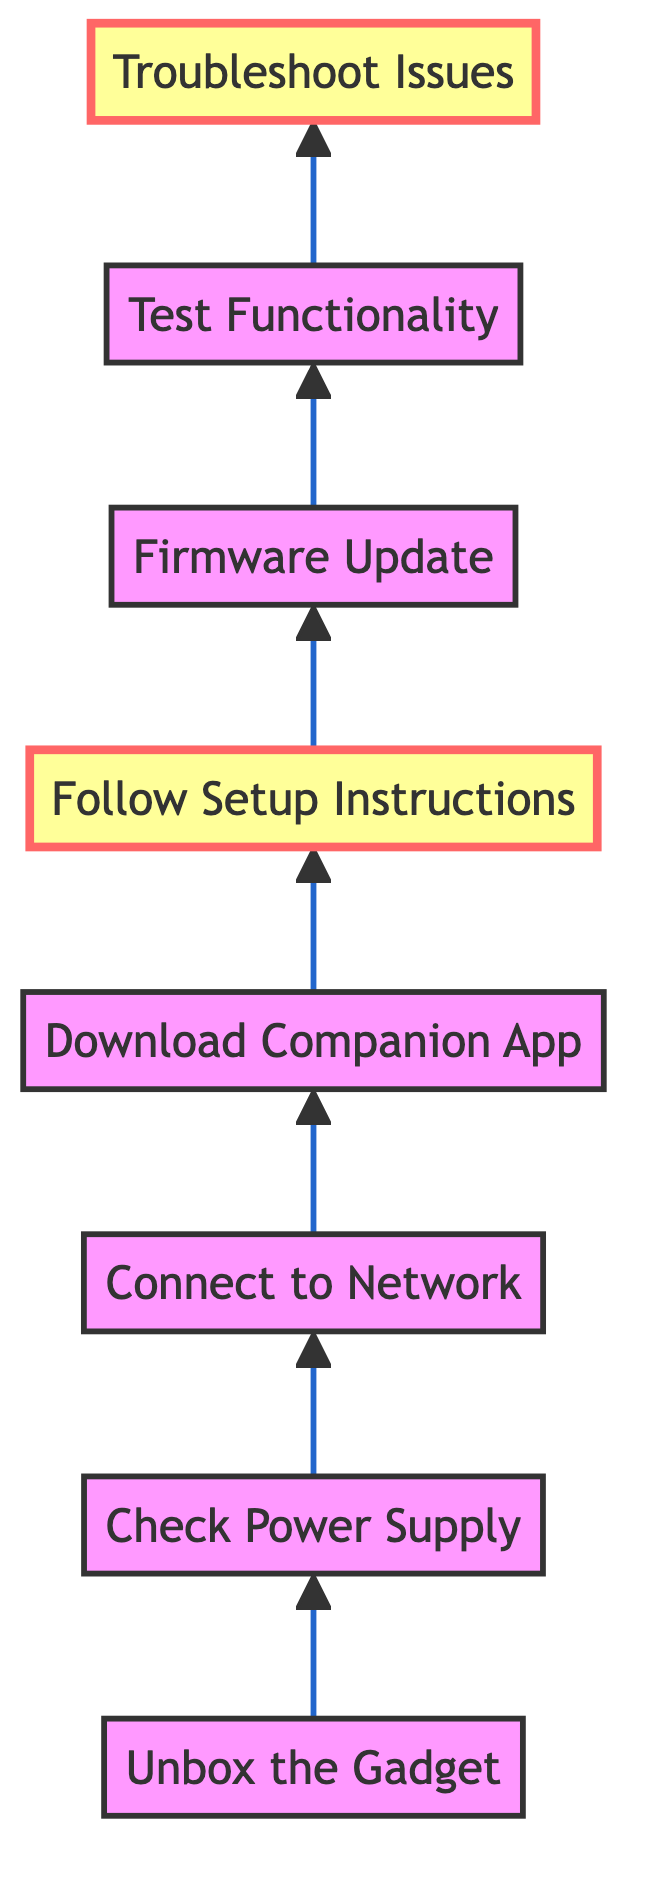What is the first step in the troubleshooting guide? The first step in the troubleshooting guide is to "Unbox the Gadget," as indicated by the starting point of the flowchart.
Answer: Unbox the Gadget How many steps are involved in the setup process? To find the total number of steps, count each node represented in the flowchart: "Unbox the Gadget," "Check Power Supply," "Connect to Network," "Download Companion App," "Follow Setup Instructions," "Firmware Update," "Test Functionality," and "Troubleshoot Issues." This totals to eight steps.
Answer: 8 What step directly follows "Download Companion App"? By following the flowchart, the step that follows "Download Companion App" is "Follow Setup Instructions" as indicated by the arrow leading to the next node.
Answer: Follow Setup Instructions What is the last step of the troubleshooting process? The last step of the troubleshooting process is "Troubleshoot Issues," which is the final node in the flowchart.
Answer: Troubleshoot Issues What are the highlighted steps in the diagram? The highlighted steps are "Follow Setup Instructions" and "Troubleshoot Issues." These are emphasized for their importance in the setup process as indicated by a different style in the flowchart.
Answer: Follow Setup Instructions, Troubleshoot Issues What step should be taken after checking for firmware updates? The step that should be taken after "Firmware Update" is "Test Functionality," as it follows directly from the firmware check in the flowchart.
Answer: Test Functionality Which step allows you to connect the gadget to your Wi-Fi? The step that allows you to connect the gadget to your Wi-Fi is "Connect to Network," as clearly indicated in the diagram's sequence.
Answer: Connect to Network What is the main purpose of downloading the companion app? The main purpose of downloading the companion app is to enable configuration and control of the gadget, which is detailed in the description of "Download Companion App."
Answer: Enable configuration and control of the gadget 